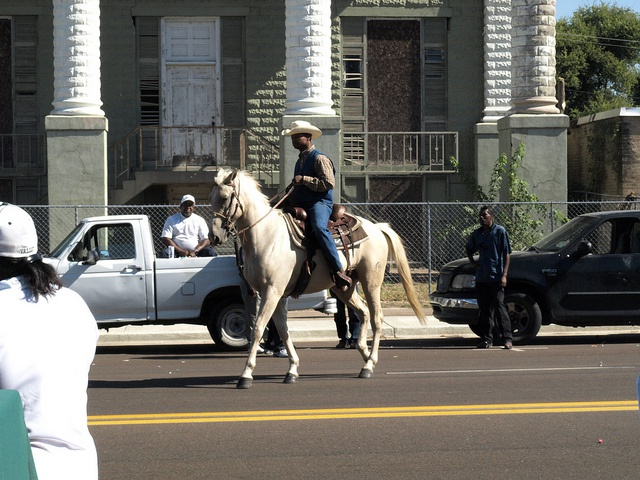Describe the objects in this image and their specific colors. I can see people in black, white, darkgray, and gray tones, horse in black, ivory, tan, and gray tones, truck in black, gray, and darkgray tones, truck in black, gray, white, and darkgray tones, and car in black, gray, and darkgray tones in this image. 